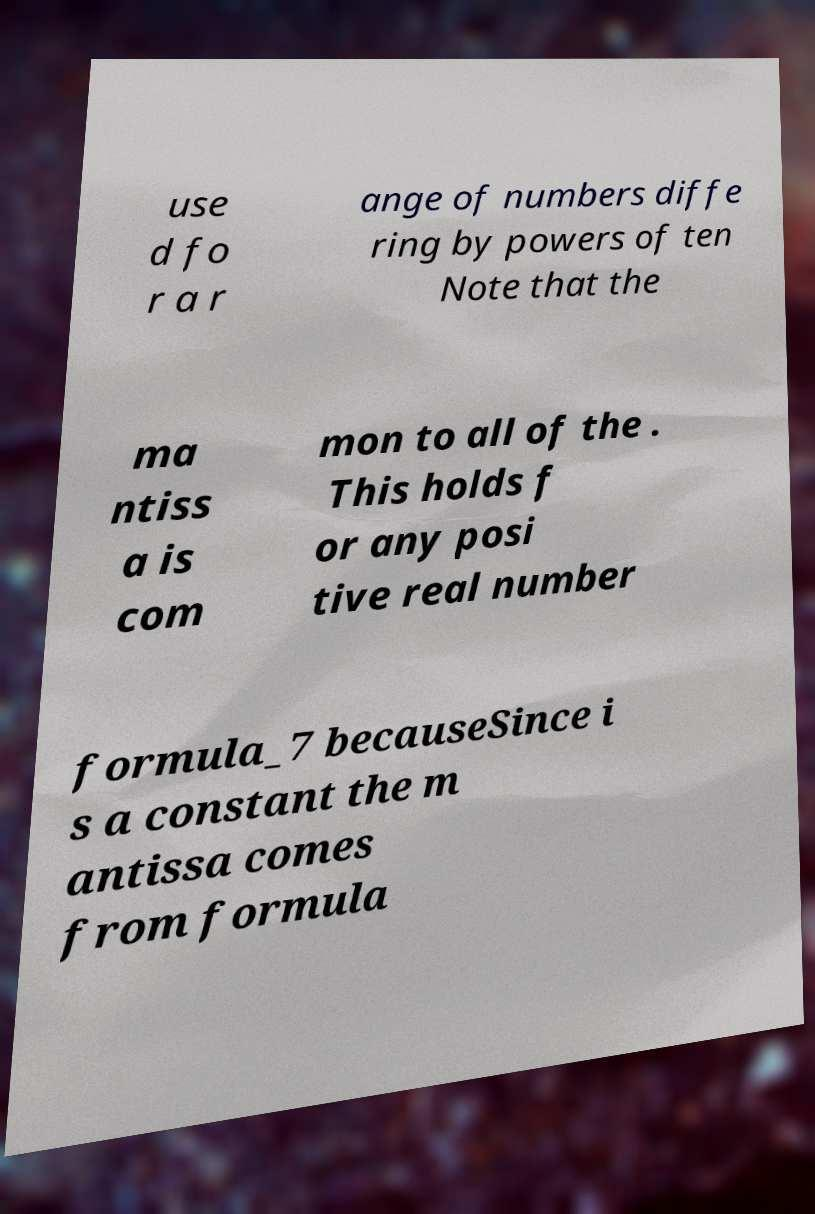There's text embedded in this image that I need extracted. Can you transcribe it verbatim? use d fo r a r ange of numbers diffe ring by powers of ten Note that the ma ntiss a is com mon to all of the . This holds f or any posi tive real number formula_7 becauseSince i s a constant the m antissa comes from formula 